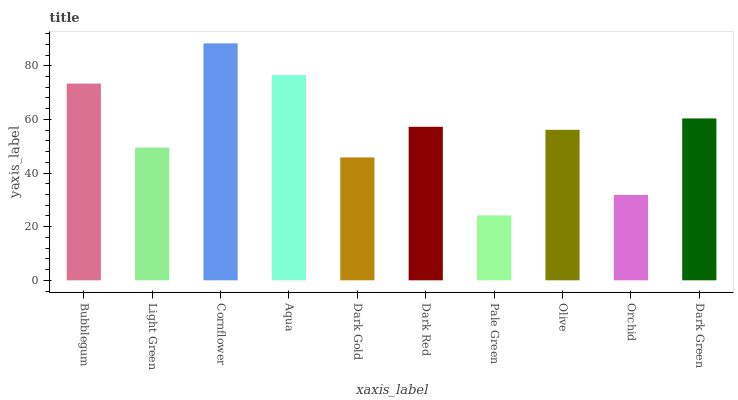Is Light Green the minimum?
Answer yes or no. No. Is Light Green the maximum?
Answer yes or no. No. Is Bubblegum greater than Light Green?
Answer yes or no. Yes. Is Light Green less than Bubblegum?
Answer yes or no. Yes. Is Light Green greater than Bubblegum?
Answer yes or no. No. Is Bubblegum less than Light Green?
Answer yes or no. No. Is Dark Red the high median?
Answer yes or no. Yes. Is Olive the low median?
Answer yes or no. Yes. Is Pale Green the high median?
Answer yes or no. No. Is Dark Red the low median?
Answer yes or no. No. 